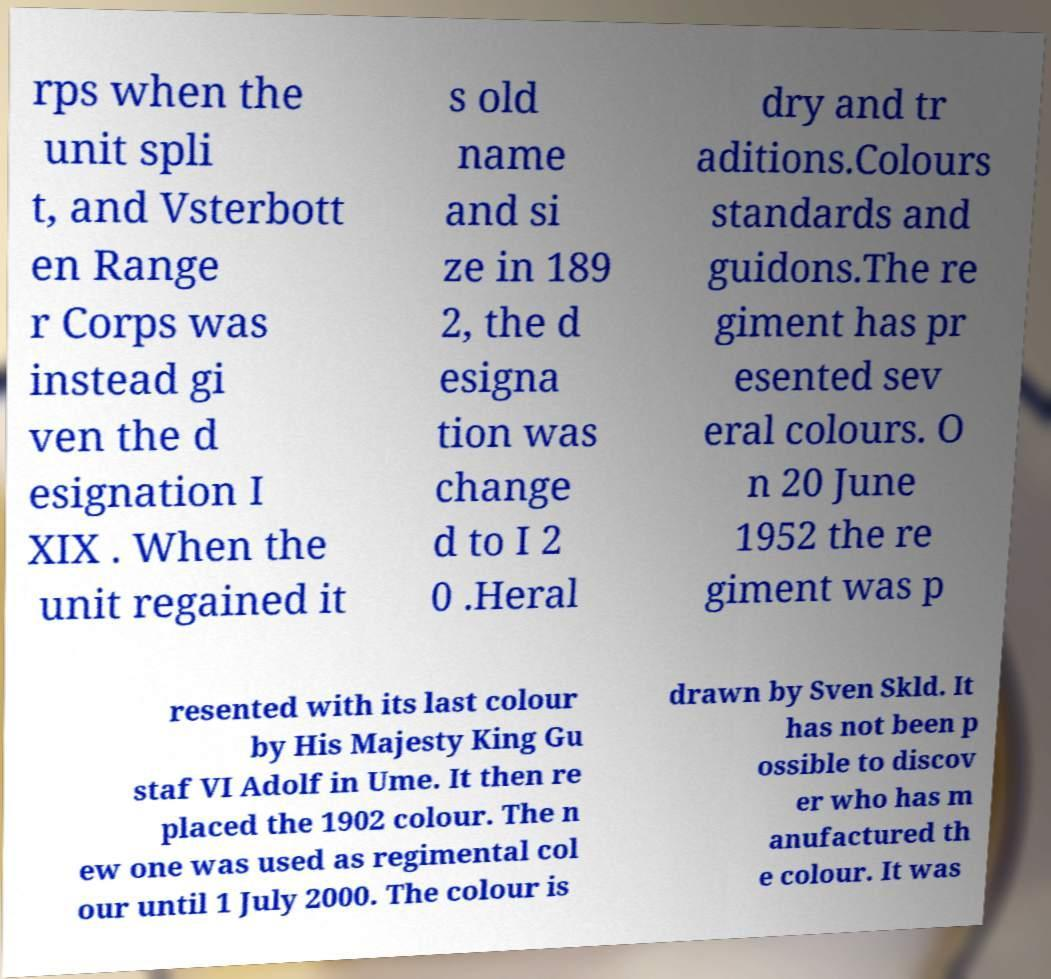There's text embedded in this image that I need extracted. Can you transcribe it verbatim? rps when the unit spli t, and Vsterbott en Range r Corps was instead gi ven the d esignation I XIX . When the unit regained it s old name and si ze in 189 2, the d esigna tion was change d to I 2 0 .Heral dry and tr aditions.Colours standards and guidons.The re giment has pr esented sev eral colours. O n 20 June 1952 the re giment was p resented with its last colour by His Majesty King Gu staf VI Adolf in Ume. It then re placed the 1902 colour. The n ew one was used as regimental col our until 1 July 2000. The colour is drawn by Sven Skld. It has not been p ossible to discov er who has m anufactured th e colour. It was 